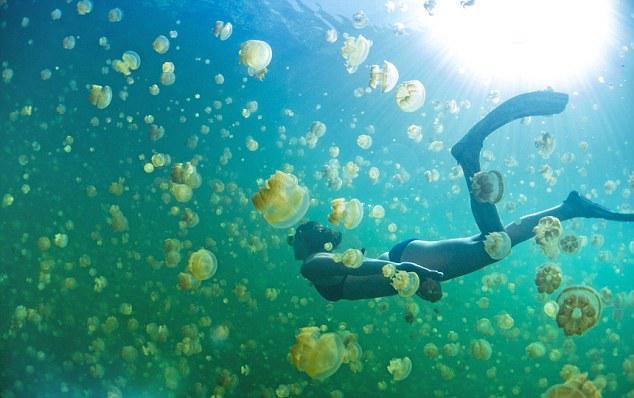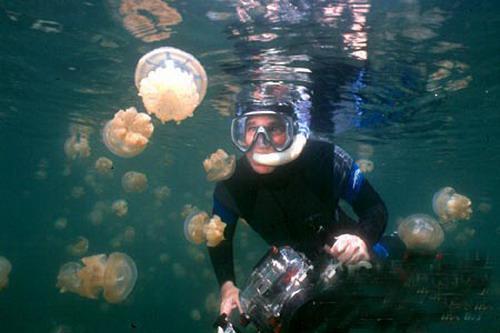The first image is the image on the left, the second image is the image on the right. Analyze the images presented: Is the assertion "A female in flippers is swimming in the image on the left." valid? Answer yes or no. Yes. The first image is the image on the left, the second image is the image on the right. Assess this claim about the two images: "A diver in a black wetsuit is near at least one pale beige mushroom-look jellyfish.". Correct or not? Answer yes or no. Yes. 